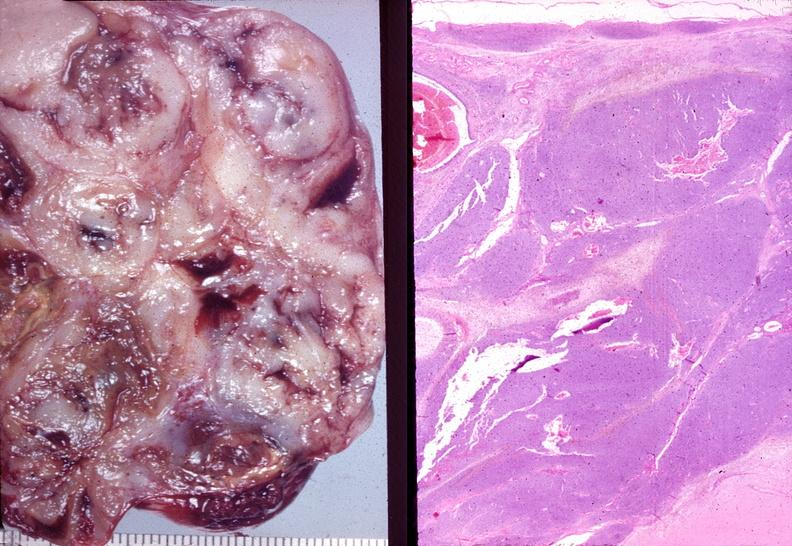what is present?
Answer the question using a single word or phrase. Female reproductive 